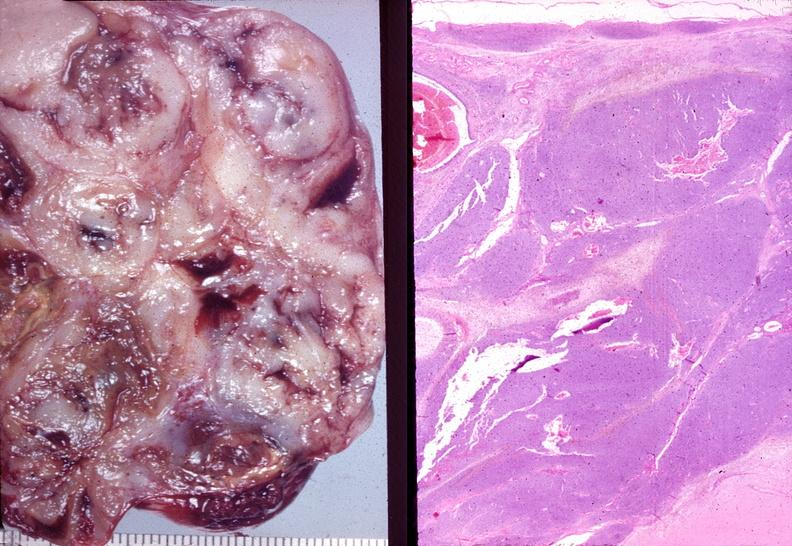what is present?
Answer the question using a single word or phrase. Female reproductive 